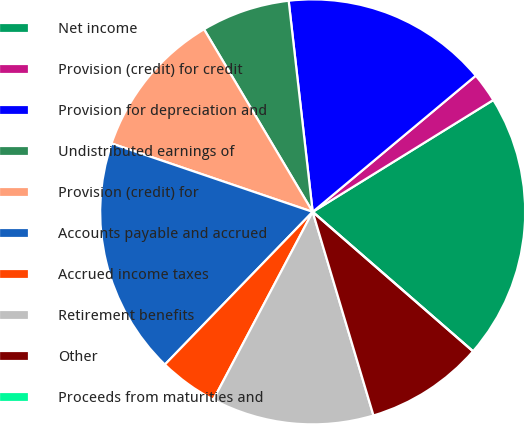Convert chart. <chart><loc_0><loc_0><loc_500><loc_500><pie_chart><fcel>Net income<fcel>Provision (credit) for credit<fcel>Provision for depreciation and<fcel>Undistributed earnings of<fcel>Provision (credit) for<fcel>Accounts payable and accrued<fcel>Accrued income taxes<fcel>Retirement benefits<fcel>Other<fcel>Proceeds from maturities and<nl><fcel>20.22%<fcel>2.25%<fcel>15.73%<fcel>6.74%<fcel>11.24%<fcel>17.98%<fcel>4.5%<fcel>12.36%<fcel>8.99%<fcel>0.0%<nl></chart> 